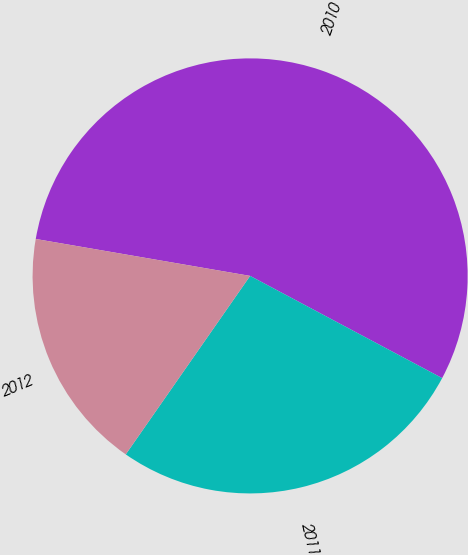Convert chart to OTSL. <chart><loc_0><loc_0><loc_500><loc_500><pie_chart><fcel>2010<fcel>2011<fcel>2012<nl><fcel>55.07%<fcel>26.9%<fcel>18.03%<nl></chart> 